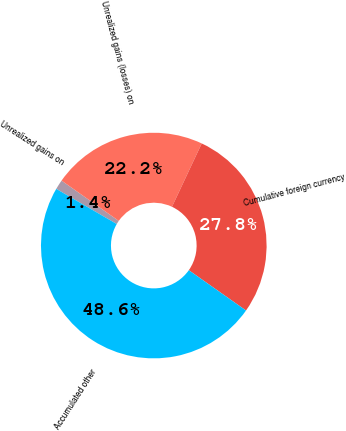<chart> <loc_0><loc_0><loc_500><loc_500><pie_chart><fcel>Unrealized gains on<fcel>Unrealized gains (losses) on<fcel>Cumulative foreign currency<fcel>Accumulated other<nl><fcel>1.39%<fcel>22.22%<fcel>27.78%<fcel>48.61%<nl></chart> 